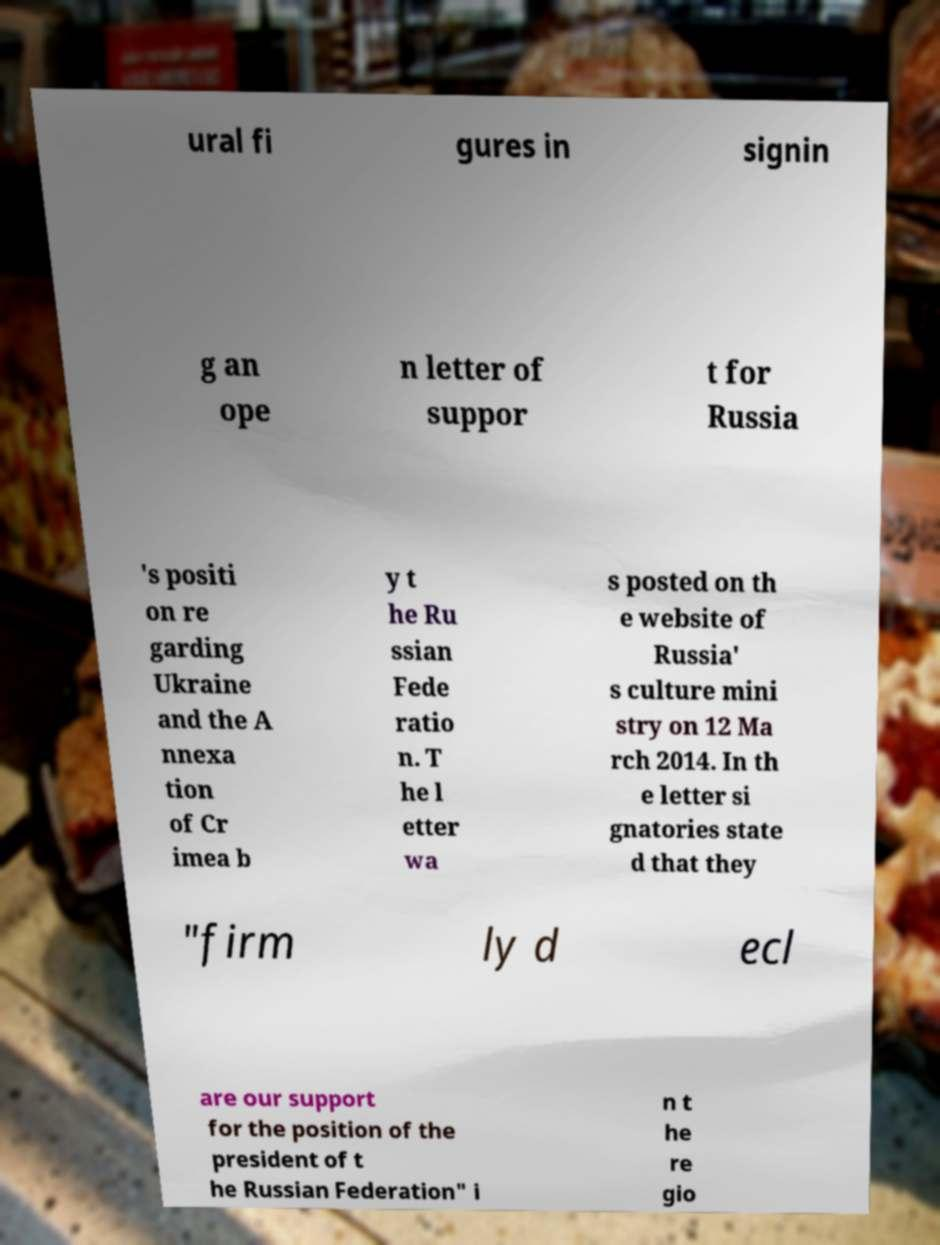Please identify and transcribe the text found in this image. ural fi gures in signin g an ope n letter of suppor t for Russia 's positi on re garding Ukraine and the A nnexa tion of Cr imea b y t he Ru ssian Fede ratio n. T he l etter wa s posted on th e website of Russia' s culture mini stry on 12 Ma rch 2014. In th e letter si gnatories state d that they "firm ly d ecl are our support for the position of the president of t he Russian Federation" i n t he re gio 